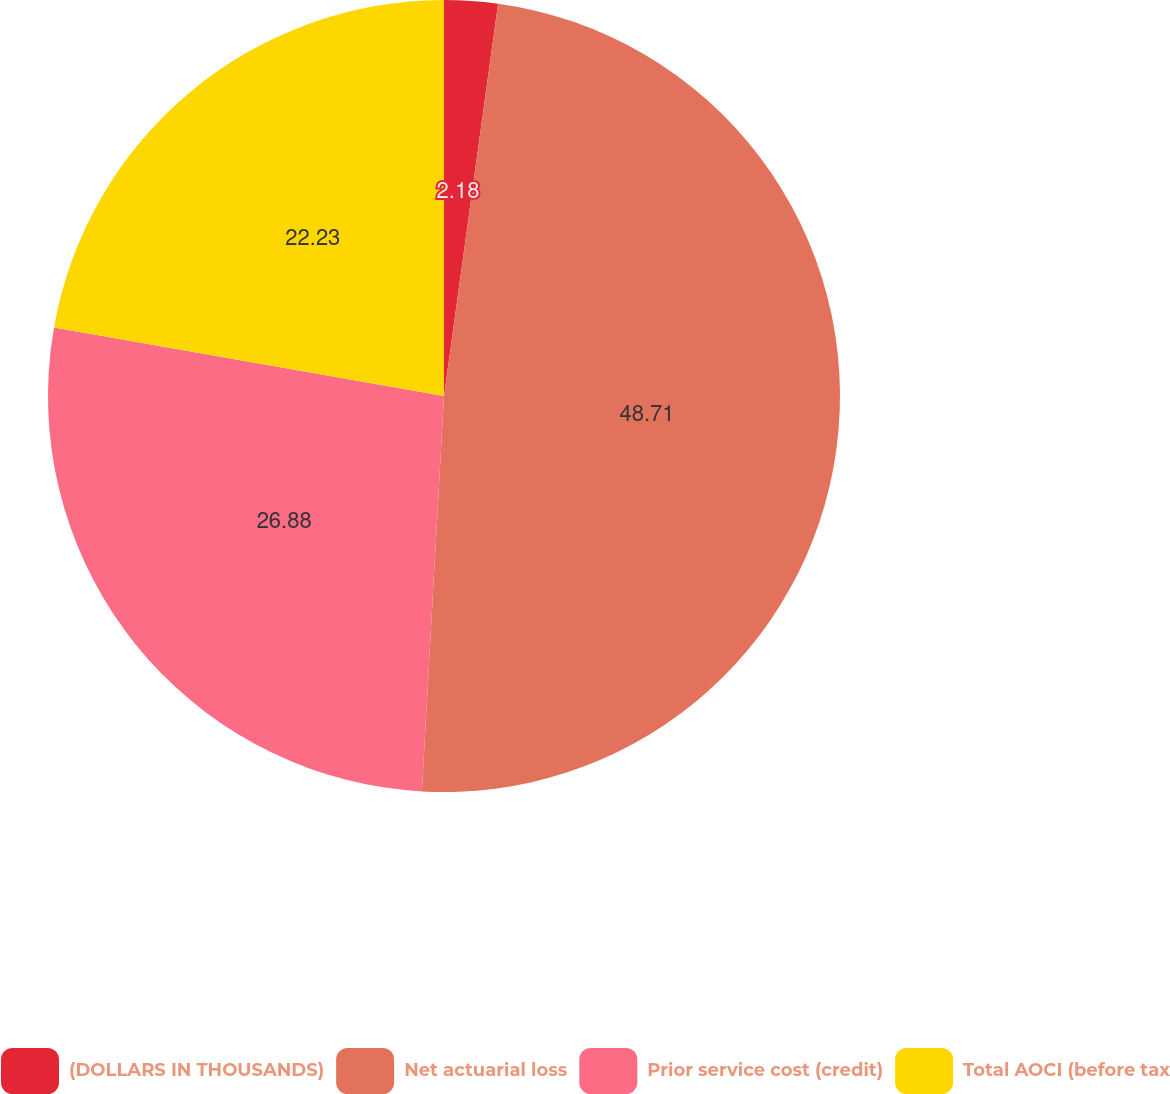<chart> <loc_0><loc_0><loc_500><loc_500><pie_chart><fcel>(DOLLARS IN THOUSANDS)<fcel>Net actuarial loss<fcel>Prior service cost (credit)<fcel>Total AOCI (before tax<nl><fcel>2.18%<fcel>48.71%<fcel>26.88%<fcel>22.23%<nl></chart> 